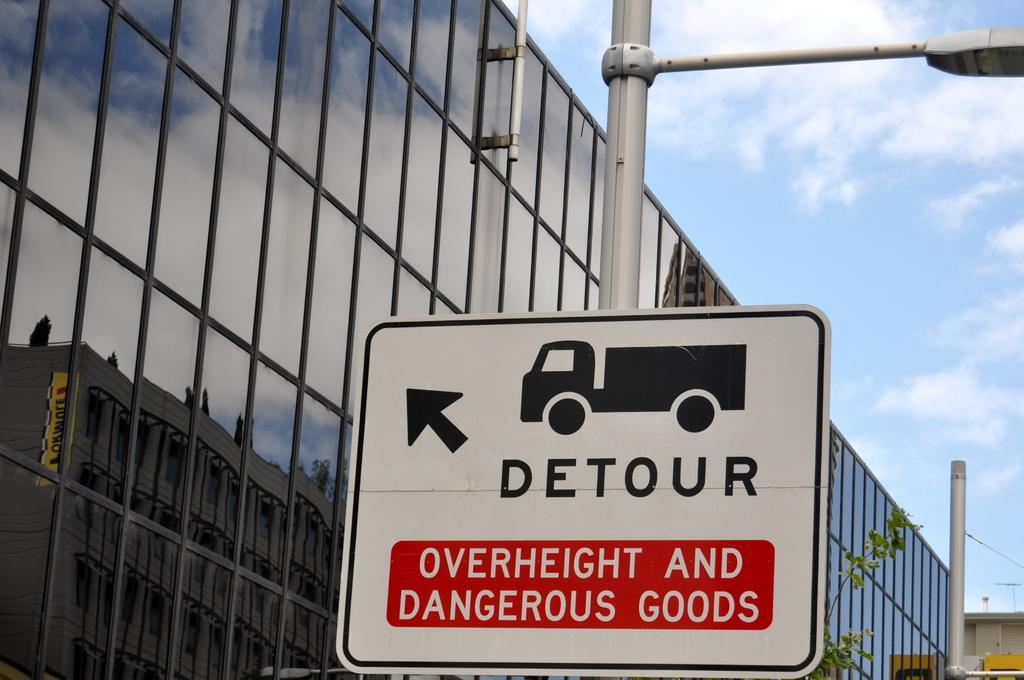<image>
Create a compact narrative representing the image presented. A sign for a detour for Overheight and Dangerous goods. 